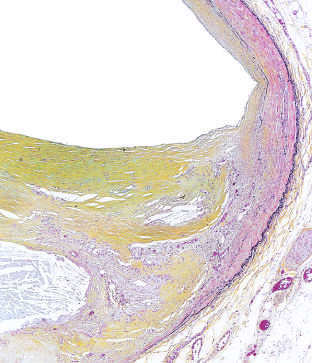what is shown in the figure, stained for elastin (black)?
Answer the question using a single word or phrase. Moderate-power view of the plaque 